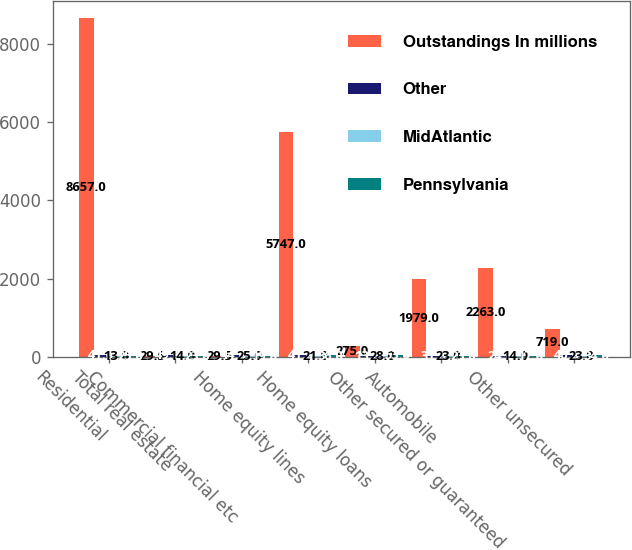Convert chart. <chart><loc_0><loc_0><loc_500><loc_500><stacked_bar_chart><ecel><fcel>Residential<fcel>Total real estate<fcel>Commercial financial etc<fcel>Home equity lines<fcel>Home equity loans<fcel>Automobile<fcel>Other secured or guaranteed<fcel>Other unsecured<nl><fcel>Outstandings In millions<fcel>8657<fcel>29.5<fcel>29.5<fcel>5747<fcel>275<fcel>1979<fcel>2263<fcel>719<nl><fcel>Other<fcel>41<fcel>49<fcel>44<fcel>41<fcel>13<fcel>31<fcel>24<fcel>40<nl><fcel>MidAtlantic<fcel>13<fcel>14<fcel>25<fcel>21<fcel>28<fcel>23<fcel>14<fcel>23<nl><fcel>Pennsylvania<fcel>25<fcel>23<fcel>19<fcel>36<fcel>53<fcel>23<fcel>17<fcel>34<nl></chart> 